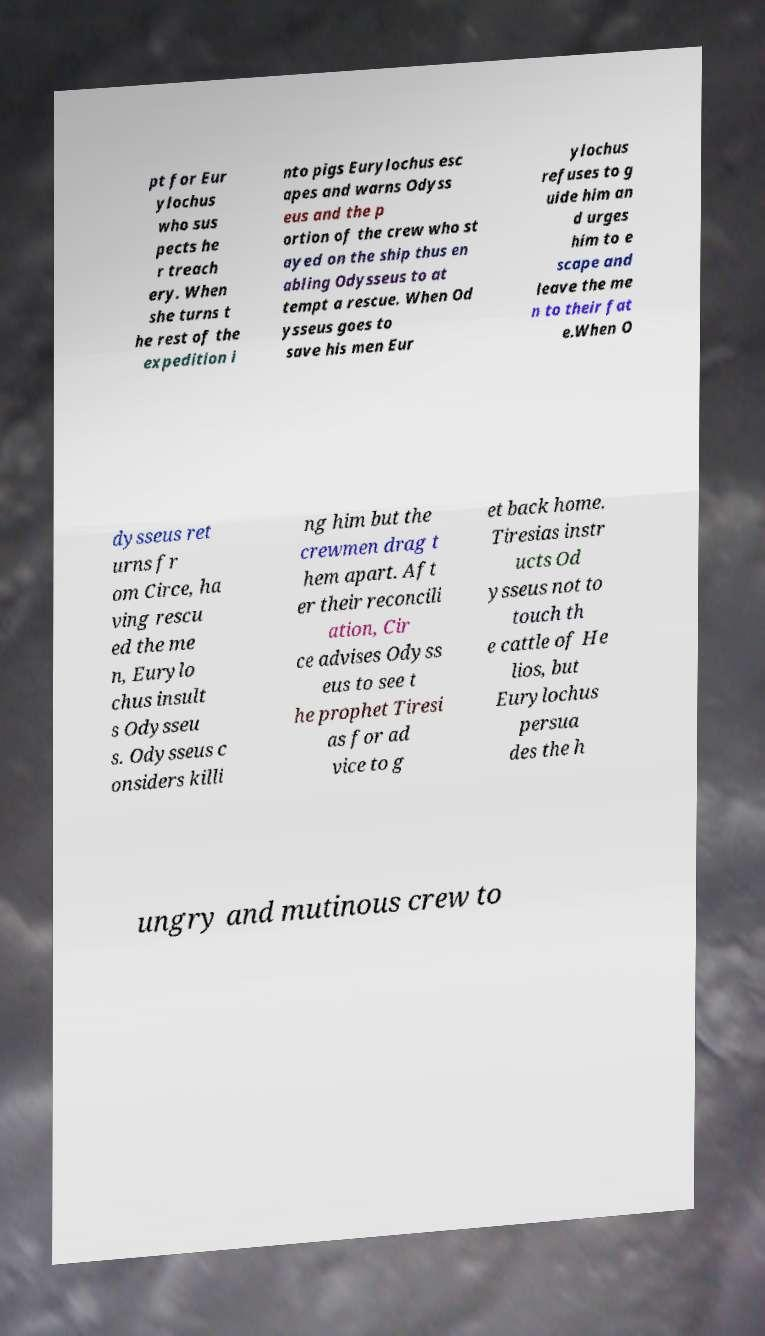Could you extract and type out the text from this image? pt for Eur ylochus who sus pects he r treach ery. When she turns t he rest of the expedition i nto pigs Eurylochus esc apes and warns Odyss eus and the p ortion of the crew who st ayed on the ship thus en abling Odysseus to at tempt a rescue. When Od ysseus goes to save his men Eur ylochus refuses to g uide him an d urges him to e scape and leave the me n to their fat e.When O dysseus ret urns fr om Circe, ha ving rescu ed the me n, Eurylo chus insult s Odysseu s. Odysseus c onsiders killi ng him but the crewmen drag t hem apart. Aft er their reconcili ation, Cir ce advises Odyss eus to see t he prophet Tiresi as for ad vice to g et back home. Tiresias instr ucts Od ysseus not to touch th e cattle of He lios, but Eurylochus persua des the h ungry and mutinous crew to 